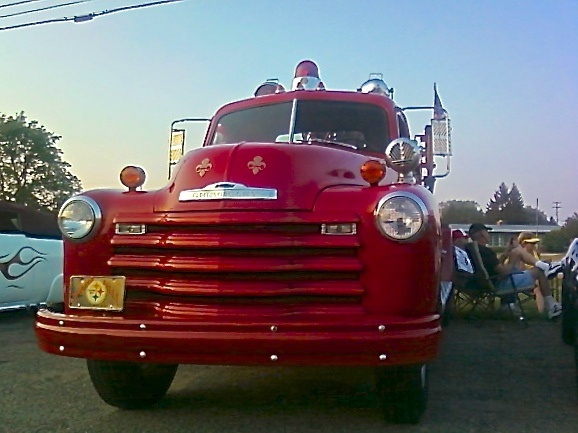Describe the objects in this image and their specific colors. I can see truck in lightblue, maroon, black, brown, and gray tones, car in lightblue, teal, black, and darkgray tones, truck in lightblue, teal, black, and darkgray tones, chair in lightblue, black, purple, darkblue, and blue tones, and people in lightblue, black, gray, blue, and darkblue tones in this image. 